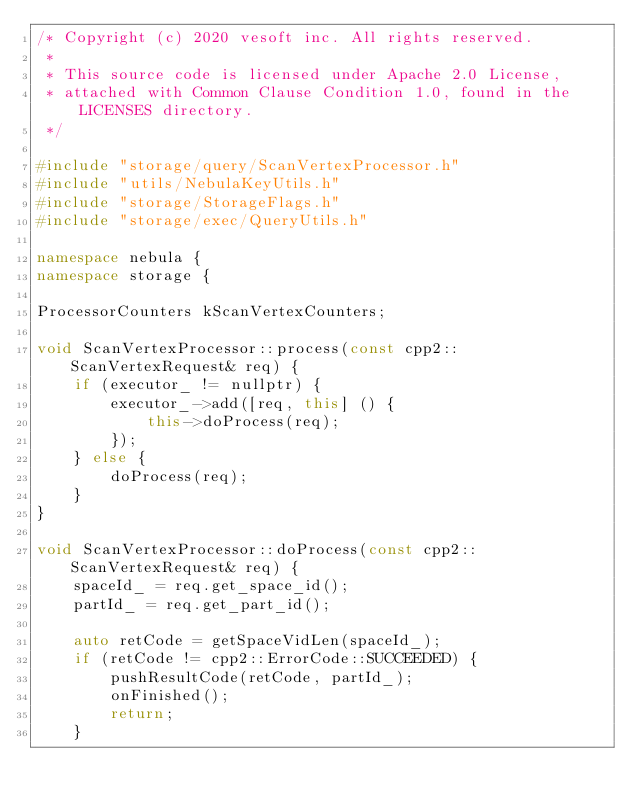<code> <loc_0><loc_0><loc_500><loc_500><_C++_>/* Copyright (c) 2020 vesoft inc. All rights reserved.
 *
 * This source code is licensed under Apache 2.0 License,
 * attached with Common Clause Condition 1.0, found in the LICENSES directory.
 */

#include "storage/query/ScanVertexProcessor.h"
#include "utils/NebulaKeyUtils.h"
#include "storage/StorageFlags.h"
#include "storage/exec/QueryUtils.h"

namespace nebula {
namespace storage {

ProcessorCounters kScanVertexCounters;

void ScanVertexProcessor::process(const cpp2::ScanVertexRequest& req) {
    if (executor_ != nullptr) {
        executor_->add([req, this] () {
            this->doProcess(req);
        });
    } else {
        doProcess(req);
    }
}

void ScanVertexProcessor::doProcess(const cpp2::ScanVertexRequest& req) {
    spaceId_ = req.get_space_id();
    partId_ = req.get_part_id();

    auto retCode = getSpaceVidLen(spaceId_);
    if (retCode != cpp2::ErrorCode::SUCCEEDED) {
        pushResultCode(retCode, partId_);
        onFinished();
        return;
    }
</code> 